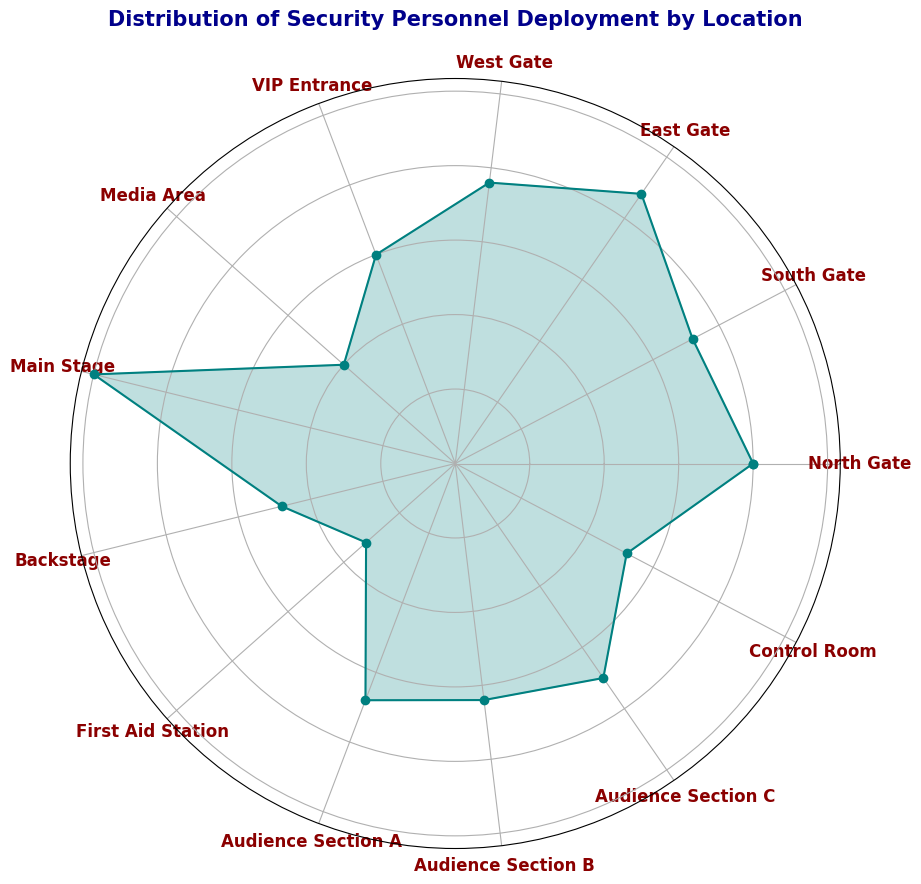Which location has the highest deployment of security personnel? Look at the location with the longest radial distance from the center; the Main Stage stands out as having the highest value.
Answer: Main Stage Between the East Gate and West Gate, which has more security personnel? Compare the radial distances of the East Gate and West Gate; the East Gate's line is longer.
Answer: East Gate What is the sum of security personnel at the back of the venue (Backstage, First Aid Station, Control Room)? Add the counts from the Backstage (120), First Aid Station (80), and Control Room (130); 120 + 80 + 130 = 330.
Answer: 330 Which is the least staffed sector? Identify the location with the shortest radial distance; the First Aid Station is the shortest.
Answer: First Aid Station How many more security personnel are at the Main Stage compared to the VIP Entrance? Subtract the VIP Entrance count (150) from the Main Stage count (250); 250 - 150 = 100.
Answer: 100 Are there more personnel deployed at the Audience Sections combined or at the Main Stage? Sum the counts of Audience Sections A, B, and C (170 + 160 + 175 = 505) and compare it to the Main Stage count (250); 505 is greater than 250.
Answer: Audience Sections combined Which of the gate locations (north, south, east, west) has the fewest personnel? Compare the radial distances for North Gate (200), South Gate (180), East Gate (220), and West Gate (190); the South Gate has the shortest line.
Answer: South Gate Is the radial distance for the Control Room deployment more or less than that for the Media Area? Compare the Control Room (130) and Media Area (100); the Control Room has a longer radial distance.
Answer: More What is the average number of security personnel across all the sectors? Sum all values: 200 + 180 + 220 + 190 + 150 + 100 + 250 + 120 + 80 + 170 + 160 + 175 + 130 = 2125; Divide by the number of sectors (13); 2125 / 13 ≈ 163.5.
Answer: 163.5 Which sector has the second highest deployment of security personnel? Identify the second longest radial distance from the center; the East Gate, after the Main Stage.
Answer: East Gate 